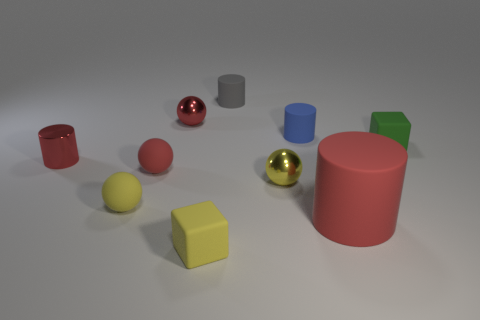There is a small gray rubber cylinder that is on the right side of the tiny red metal cylinder; how many small matte things are to the left of it?
Give a very brief answer. 3. Are there more small red balls that are in front of the tiny yellow matte block than blue matte things in front of the tiny green rubber thing?
Your response must be concise. No. What is the material of the large cylinder?
Provide a short and direct response. Rubber. Is there another matte object that has the same size as the green object?
Provide a succinct answer. Yes. There is a blue thing that is the same size as the green rubber cube; what is it made of?
Make the answer very short. Rubber. How many tiny cubes are there?
Your answer should be compact. 2. How big is the cylinder that is on the left side of the yellow block?
Your answer should be very brief. Small. Is the number of tiny green rubber blocks that are to the right of the large red cylinder the same as the number of tiny cyan rubber blocks?
Give a very brief answer. No. Is there a red metal object that has the same shape as the blue rubber object?
Offer a terse response. Yes. What shape is the rubber object that is both right of the gray cylinder and on the left side of the large red object?
Offer a terse response. Cylinder. 